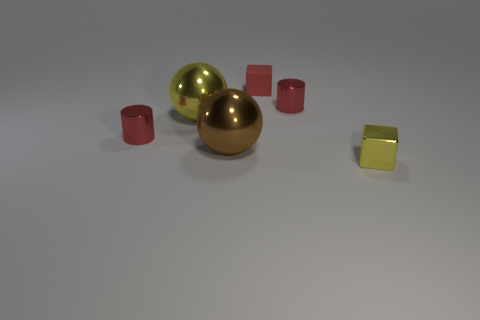What is the color of the metallic cylinder right of the red metallic cylinder that is on the left side of the small red matte object?
Keep it short and to the point. Red. There is a matte thing that is the same size as the metallic block; what is its color?
Provide a short and direct response. Red. Are there any shiny spheres of the same color as the tiny matte block?
Give a very brief answer. No. Are there any large brown balls?
Give a very brief answer. Yes. What shape is the small shiny thing that is to the left of the matte object?
Offer a very short reply. Cylinder. How many small shiny things are both to the left of the rubber block and in front of the brown metallic object?
Ensure brevity in your answer.  0. How many other things are there of the same size as the brown ball?
Your response must be concise. 1. There is a yellow shiny object that is to the left of the tiny shiny cube; is it the same shape as the red metallic thing that is on the left side of the big brown ball?
Keep it short and to the point. No. How many objects are either blocks or metal objects behind the brown metallic sphere?
Make the answer very short. 5. The small thing that is in front of the big yellow sphere and behind the shiny cube is made of what material?
Your answer should be very brief. Metal. 